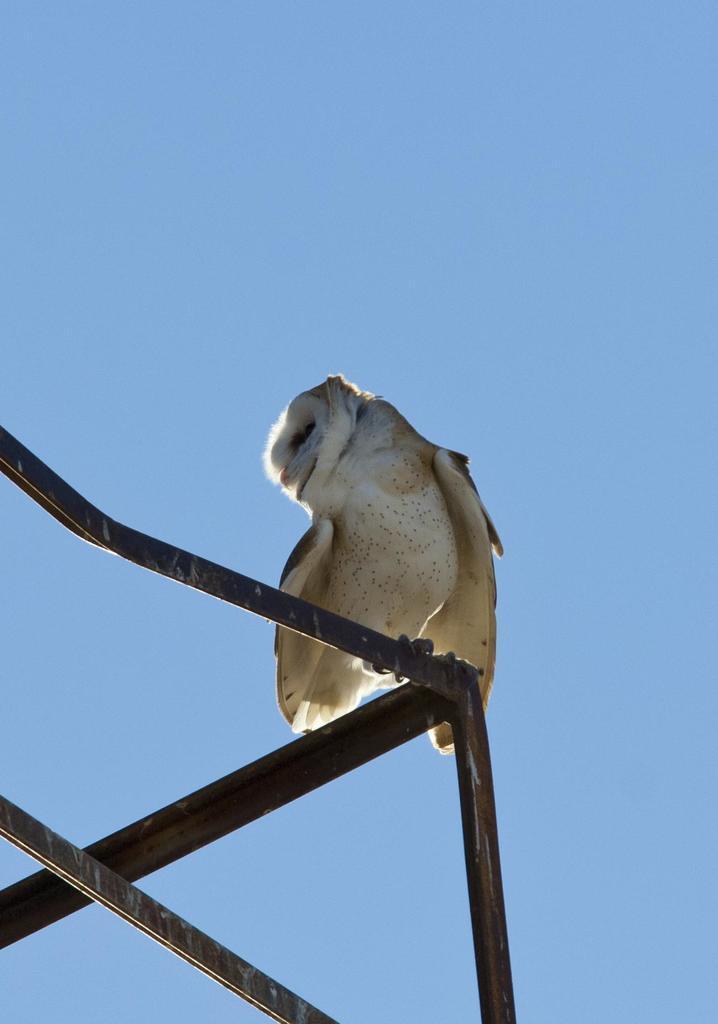In one or two sentences, can you explain what this image depicts? This picture shows a bird on the metal fence it is white and brown in color and we see a blue sky. 